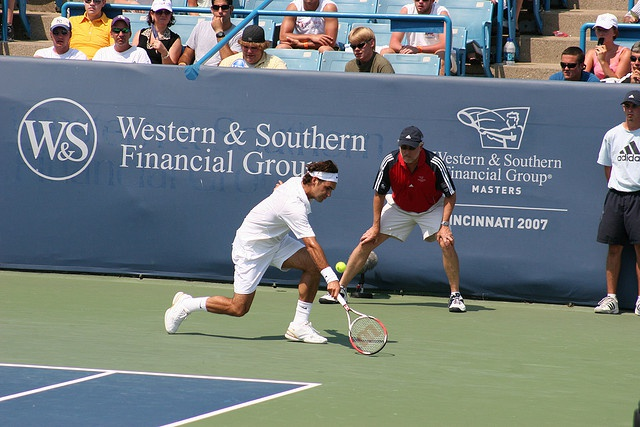Describe the objects in this image and their specific colors. I can see people in black, white, darkgray, and maroon tones, people in black, maroon, gray, and darkgray tones, people in black, white, gray, and maroon tones, people in black, salmon, white, and maroon tones, and people in black, lightgray, brown, and maroon tones in this image. 